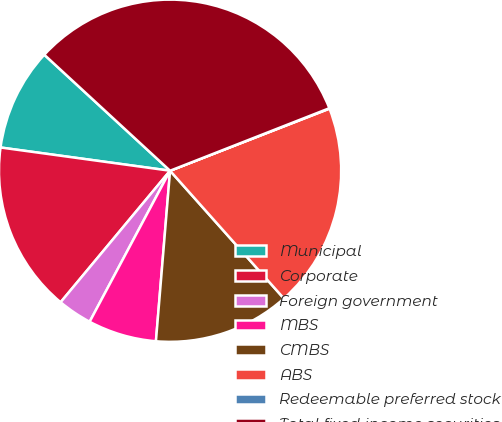Convert chart. <chart><loc_0><loc_0><loc_500><loc_500><pie_chart><fcel>Municipal<fcel>Corporate<fcel>Foreign government<fcel>MBS<fcel>CMBS<fcel>ABS<fcel>Redeemable preferred stock<fcel>Total fixed income securities<nl><fcel>9.69%<fcel>16.12%<fcel>3.26%<fcel>6.47%<fcel>12.9%<fcel>19.33%<fcel>0.04%<fcel>32.19%<nl></chart> 